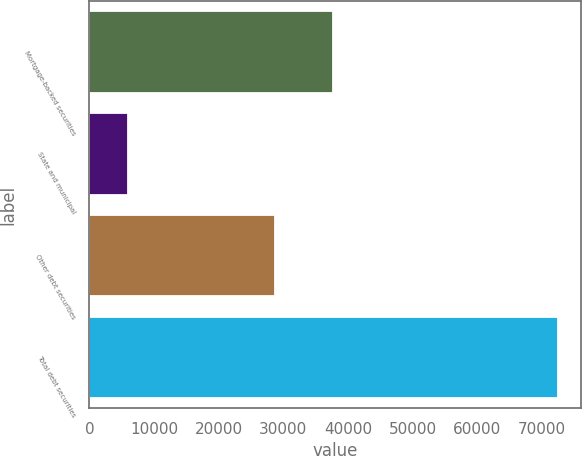Convert chart. <chart><loc_0><loc_0><loc_500><loc_500><bar_chart><fcel>Mortgage-backed securities<fcel>State and municipal<fcel>Other debt securities<fcel>Total debt securities<nl><fcel>37719<fcel>6051<fcel>28708<fcel>72478<nl></chart> 